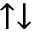Convert formula to latex. <formula><loc_0><loc_0><loc_500><loc_500>\uparrow \downarrow</formula> 